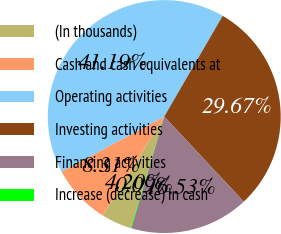Convert chart to OTSL. <chart><loc_0><loc_0><loc_500><loc_500><pie_chart><fcel>(In thousands)<fcel>Cash and cash equivalents at<fcel>Operating activities<fcel>Investing activities<fcel>Financing activities<fcel>Increase (decrease) in cash<nl><fcel>4.2%<fcel>8.31%<fcel>41.19%<fcel>29.67%<fcel>16.53%<fcel>0.09%<nl></chart> 